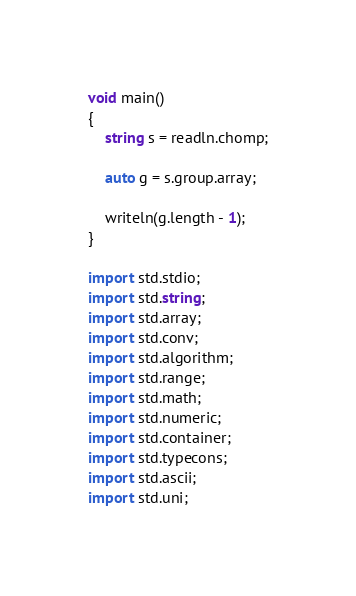Convert code to text. <code><loc_0><loc_0><loc_500><loc_500><_D_>void main()
{
    string s = readln.chomp;

    auto g = s.group.array;

    writeln(g.length - 1);
}

import std.stdio;
import std.string;
import std.array;
import std.conv;
import std.algorithm;
import std.range;
import std.math;
import std.numeric;
import std.container;
import std.typecons;
import std.ascii;
import std.uni;</code> 